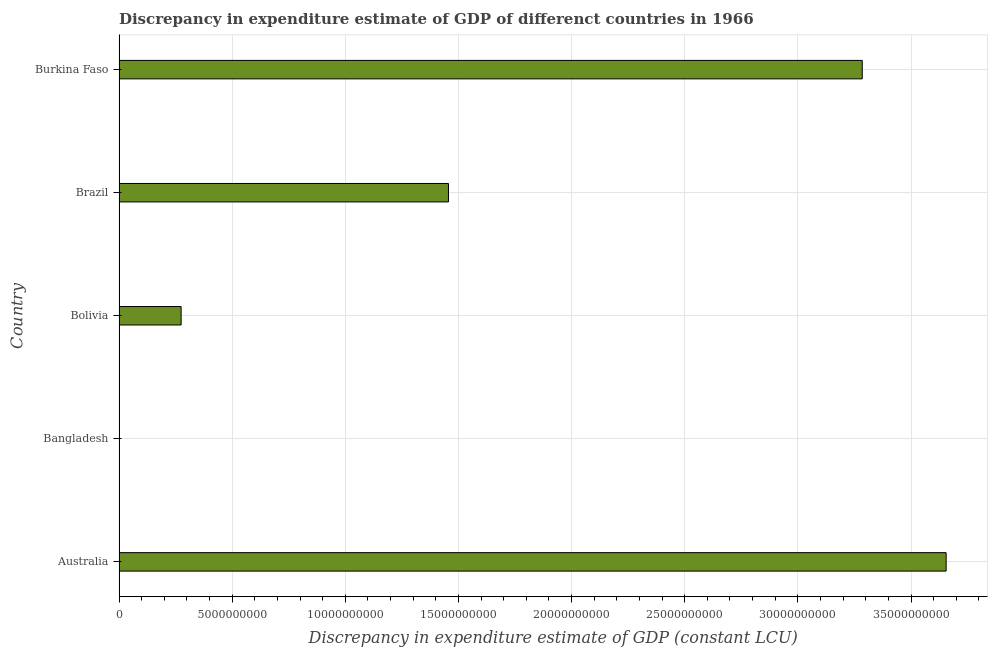Does the graph contain any zero values?
Give a very brief answer. Yes. Does the graph contain grids?
Make the answer very short. Yes. What is the title of the graph?
Offer a very short reply. Discrepancy in expenditure estimate of GDP of differenct countries in 1966. What is the label or title of the X-axis?
Offer a very short reply. Discrepancy in expenditure estimate of GDP (constant LCU). What is the discrepancy in expenditure estimate of gdp in Brazil?
Your answer should be very brief. 1.46e+1. Across all countries, what is the maximum discrepancy in expenditure estimate of gdp?
Make the answer very short. 3.66e+1. Across all countries, what is the minimum discrepancy in expenditure estimate of gdp?
Offer a very short reply. 0. In which country was the discrepancy in expenditure estimate of gdp maximum?
Your answer should be very brief. Australia. What is the sum of the discrepancy in expenditure estimate of gdp?
Offer a very short reply. 8.67e+1. What is the difference between the discrepancy in expenditure estimate of gdp in Australia and Brazil?
Ensure brevity in your answer.  2.20e+1. What is the average discrepancy in expenditure estimate of gdp per country?
Offer a very short reply. 1.73e+1. What is the median discrepancy in expenditure estimate of gdp?
Provide a succinct answer. 1.46e+1. In how many countries, is the discrepancy in expenditure estimate of gdp greater than 24000000000 LCU?
Keep it short and to the point. 2. What is the ratio of the discrepancy in expenditure estimate of gdp in Bolivia to that in Brazil?
Your response must be concise. 0.19. What is the difference between the highest and the second highest discrepancy in expenditure estimate of gdp?
Make the answer very short. 3.71e+09. Is the sum of the discrepancy in expenditure estimate of gdp in Brazil and Burkina Faso greater than the maximum discrepancy in expenditure estimate of gdp across all countries?
Offer a terse response. Yes. What is the difference between the highest and the lowest discrepancy in expenditure estimate of gdp?
Your answer should be very brief. 3.66e+1. How many bars are there?
Ensure brevity in your answer.  4. Are all the bars in the graph horizontal?
Provide a succinct answer. Yes. How many countries are there in the graph?
Ensure brevity in your answer.  5. What is the difference between two consecutive major ticks on the X-axis?
Your answer should be very brief. 5.00e+09. What is the Discrepancy in expenditure estimate of GDP (constant LCU) in Australia?
Give a very brief answer. 3.66e+1. What is the Discrepancy in expenditure estimate of GDP (constant LCU) of Bangladesh?
Offer a very short reply. 0. What is the Discrepancy in expenditure estimate of GDP (constant LCU) of Bolivia?
Keep it short and to the point. 2.74e+09. What is the Discrepancy in expenditure estimate of GDP (constant LCU) in Brazil?
Make the answer very short. 1.46e+1. What is the Discrepancy in expenditure estimate of GDP (constant LCU) of Burkina Faso?
Your answer should be very brief. 3.28e+1. What is the difference between the Discrepancy in expenditure estimate of GDP (constant LCU) in Australia and Bolivia?
Offer a very short reply. 3.38e+1. What is the difference between the Discrepancy in expenditure estimate of GDP (constant LCU) in Australia and Brazil?
Your answer should be very brief. 2.20e+1. What is the difference between the Discrepancy in expenditure estimate of GDP (constant LCU) in Australia and Burkina Faso?
Your answer should be very brief. 3.71e+09. What is the difference between the Discrepancy in expenditure estimate of GDP (constant LCU) in Bolivia and Brazil?
Provide a succinct answer. -1.18e+1. What is the difference between the Discrepancy in expenditure estimate of GDP (constant LCU) in Bolivia and Burkina Faso?
Keep it short and to the point. -3.01e+1. What is the difference between the Discrepancy in expenditure estimate of GDP (constant LCU) in Brazil and Burkina Faso?
Give a very brief answer. -1.83e+1. What is the ratio of the Discrepancy in expenditure estimate of GDP (constant LCU) in Australia to that in Bolivia?
Give a very brief answer. 13.32. What is the ratio of the Discrepancy in expenditure estimate of GDP (constant LCU) in Australia to that in Brazil?
Make the answer very short. 2.51. What is the ratio of the Discrepancy in expenditure estimate of GDP (constant LCU) in Australia to that in Burkina Faso?
Provide a short and direct response. 1.11. What is the ratio of the Discrepancy in expenditure estimate of GDP (constant LCU) in Bolivia to that in Brazil?
Ensure brevity in your answer.  0.19. What is the ratio of the Discrepancy in expenditure estimate of GDP (constant LCU) in Bolivia to that in Burkina Faso?
Your response must be concise. 0.08. What is the ratio of the Discrepancy in expenditure estimate of GDP (constant LCU) in Brazil to that in Burkina Faso?
Your answer should be very brief. 0.44. 